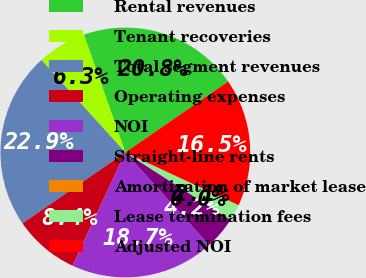Convert chart to OTSL. <chart><loc_0><loc_0><loc_500><loc_500><pie_chart><fcel>Rental revenues<fcel>Tenant recoveries<fcel>Total segment revenues<fcel>Operating expenses<fcel>NOI<fcel>Straight-line rents<fcel>Amortization of market lease<fcel>Lease termination fees<fcel>Adjusted NOI<nl><fcel>20.77%<fcel>6.34%<fcel>22.88%<fcel>8.45%<fcel>18.66%<fcel>4.23%<fcel>0.01%<fcel>2.12%<fcel>16.55%<nl></chart> 